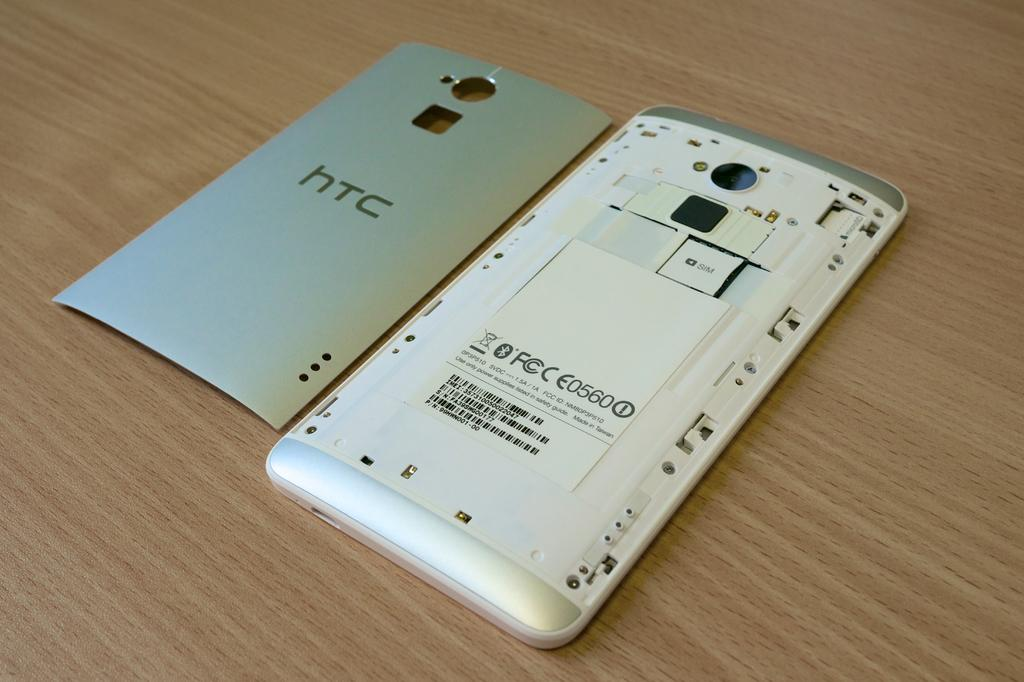<image>
Provide a brief description of the given image. htc cellphone with the back cover removed  so that sim card and battery labeled E0560 battery is visible 